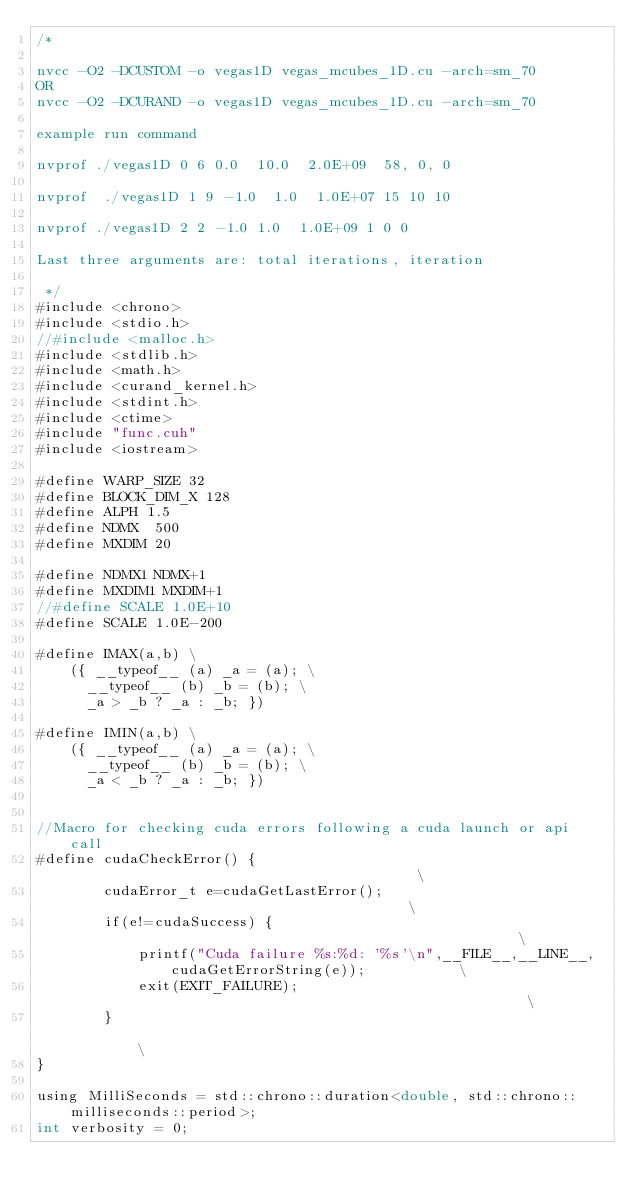Convert code to text. <code><loc_0><loc_0><loc_500><loc_500><_Cuda_>/*

nvcc -O2 -DCUSTOM -o vegas1D vegas_mcubes_1D.cu -arch=sm_70
OR
nvcc -O2 -DCURAND -o vegas1D vegas_mcubes_1D.cu -arch=sm_70

example run command

nvprof ./vegas1D 0 6 0.0  10.0  2.0E+09  58, 0, 0

nvprof  ./vegas1D 1 9 -1.0  1.0  1.0E+07 15 10 10

nvprof ./vegas1D 2 2 -1.0 1.0  1.0E+09 1 0 0

Last three arguments are: total iterations, iteration

 */
#include <chrono>
#include <stdio.h>
//#include <malloc.h>
#include <stdlib.h>
#include <math.h>
#include <curand_kernel.h>
#include <stdint.h>
#include <ctime>
#include "func.cuh"
#include <iostream>

#define WARP_SIZE 32
#define BLOCK_DIM_X 128
#define ALPH 1.5
#define NDMX  500
#define MXDIM 20

#define NDMX1 NDMX+1
#define MXDIM1 MXDIM+1
//#define SCALE 1.0E+10
#define SCALE 1.0E-200

#define IMAX(a,b) \
    ({ __typeof__ (a) _a = (a); \
      __typeof__ (b) _b = (b); \
      _a > _b ? _a : _b; })

#define IMIN(a,b) \
    ({ __typeof__ (a) _a = (a); \
      __typeof__ (b) _b = (b); \
      _a < _b ? _a : _b; })


//Macro for checking cuda errors following a cuda launch or api call
#define cudaCheckError() {                                          \
        cudaError_t e=cudaGetLastError();                                 \
        if(e!=cudaSuccess) {                                              \
            printf("Cuda failure %s:%d: '%s'\n",__FILE__,__LINE__,cudaGetErrorString(e));           \
            exit(EXIT_FAILURE);                                           \
        }                                                                 \
}

using MilliSeconds = std::chrono::duration<double, std::chrono::milliseconds::period>;
int verbosity = 0;</code> 